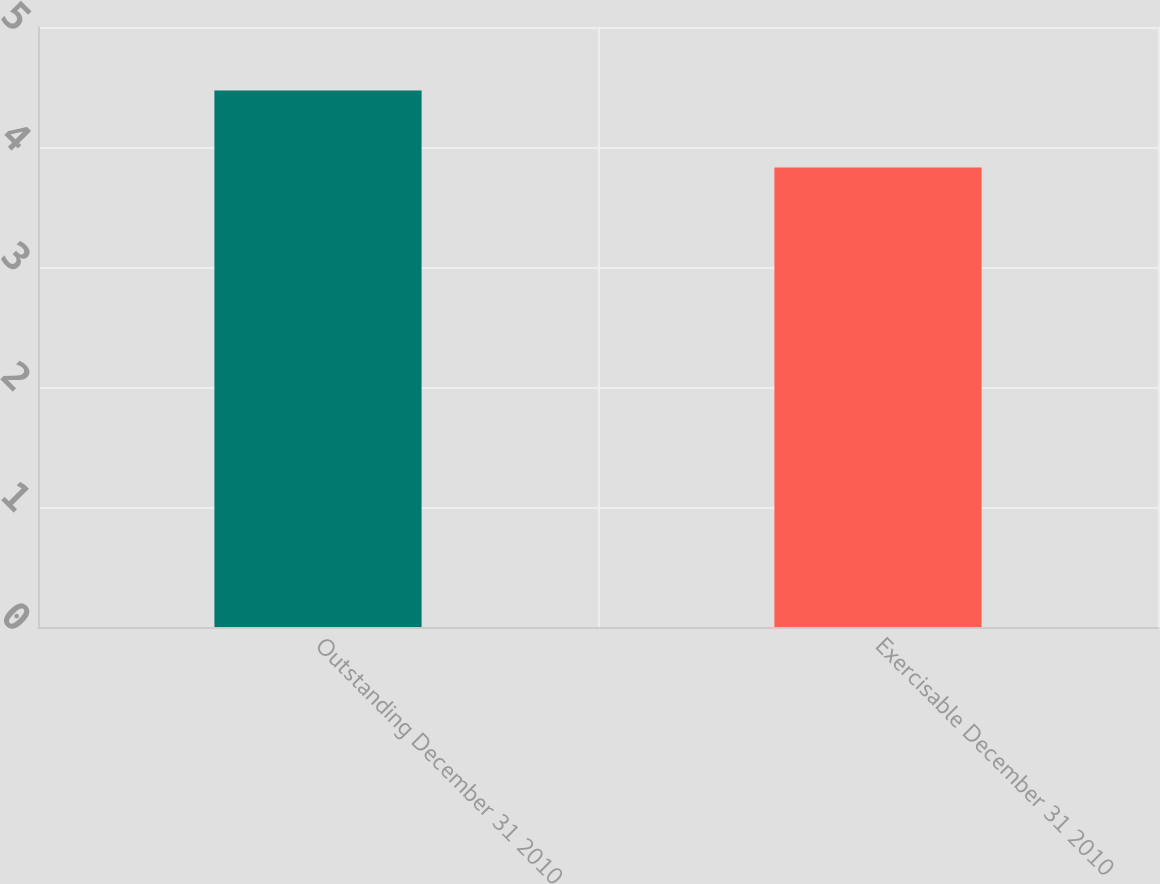<chart> <loc_0><loc_0><loc_500><loc_500><bar_chart><fcel>Outstanding December 31 2010<fcel>Exercisable December 31 2010<nl><fcel>4.47<fcel>3.83<nl></chart> 